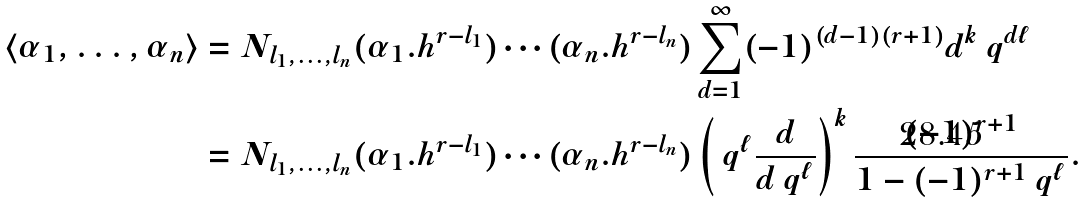<formula> <loc_0><loc_0><loc_500><loc_500>\left < \alpha _ { 1 } , \dots , \alpha _ { n } \right > & = N _ { l _ { 1 } , \dots , l _ { n } } ( \alpha _ { 1 } . h ^ { r - l _ { 1 } } ) \cdots ( \alpha _ { n } . h ^ { r - l _ { n } } ) \sum _ { d = 1 } ^ { \infty } ( - 1 ) ^ { ( d - 1 ) ( r + 1 ) } d ^ { k } \ q ^ { d \ell } \\ & = N _ { l _ { 1 } , \dots , l _ { n } } ( \alpha _ { 1 } . h ^ { r - l _ { 1 } } ) \cdots ( \alpha _ { n } . h ^ { r - l _ { n } } ) \left ( \ q ^ { \ell } \frac { d } { d \ q ^ { \ell } } \right ) ^ { k } \frac { ( - 1 ) ^ { r + 1 } } { 1 - ( - 1 ) ^ { r + 1 } \ q ^ { \ell } } .</formula> 